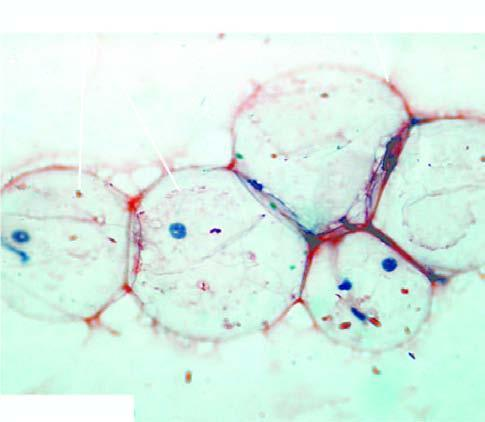s abdominal fat aspirate stained with congo red stain for amyloid?
Answer the question using a single word or phrase. Yes 